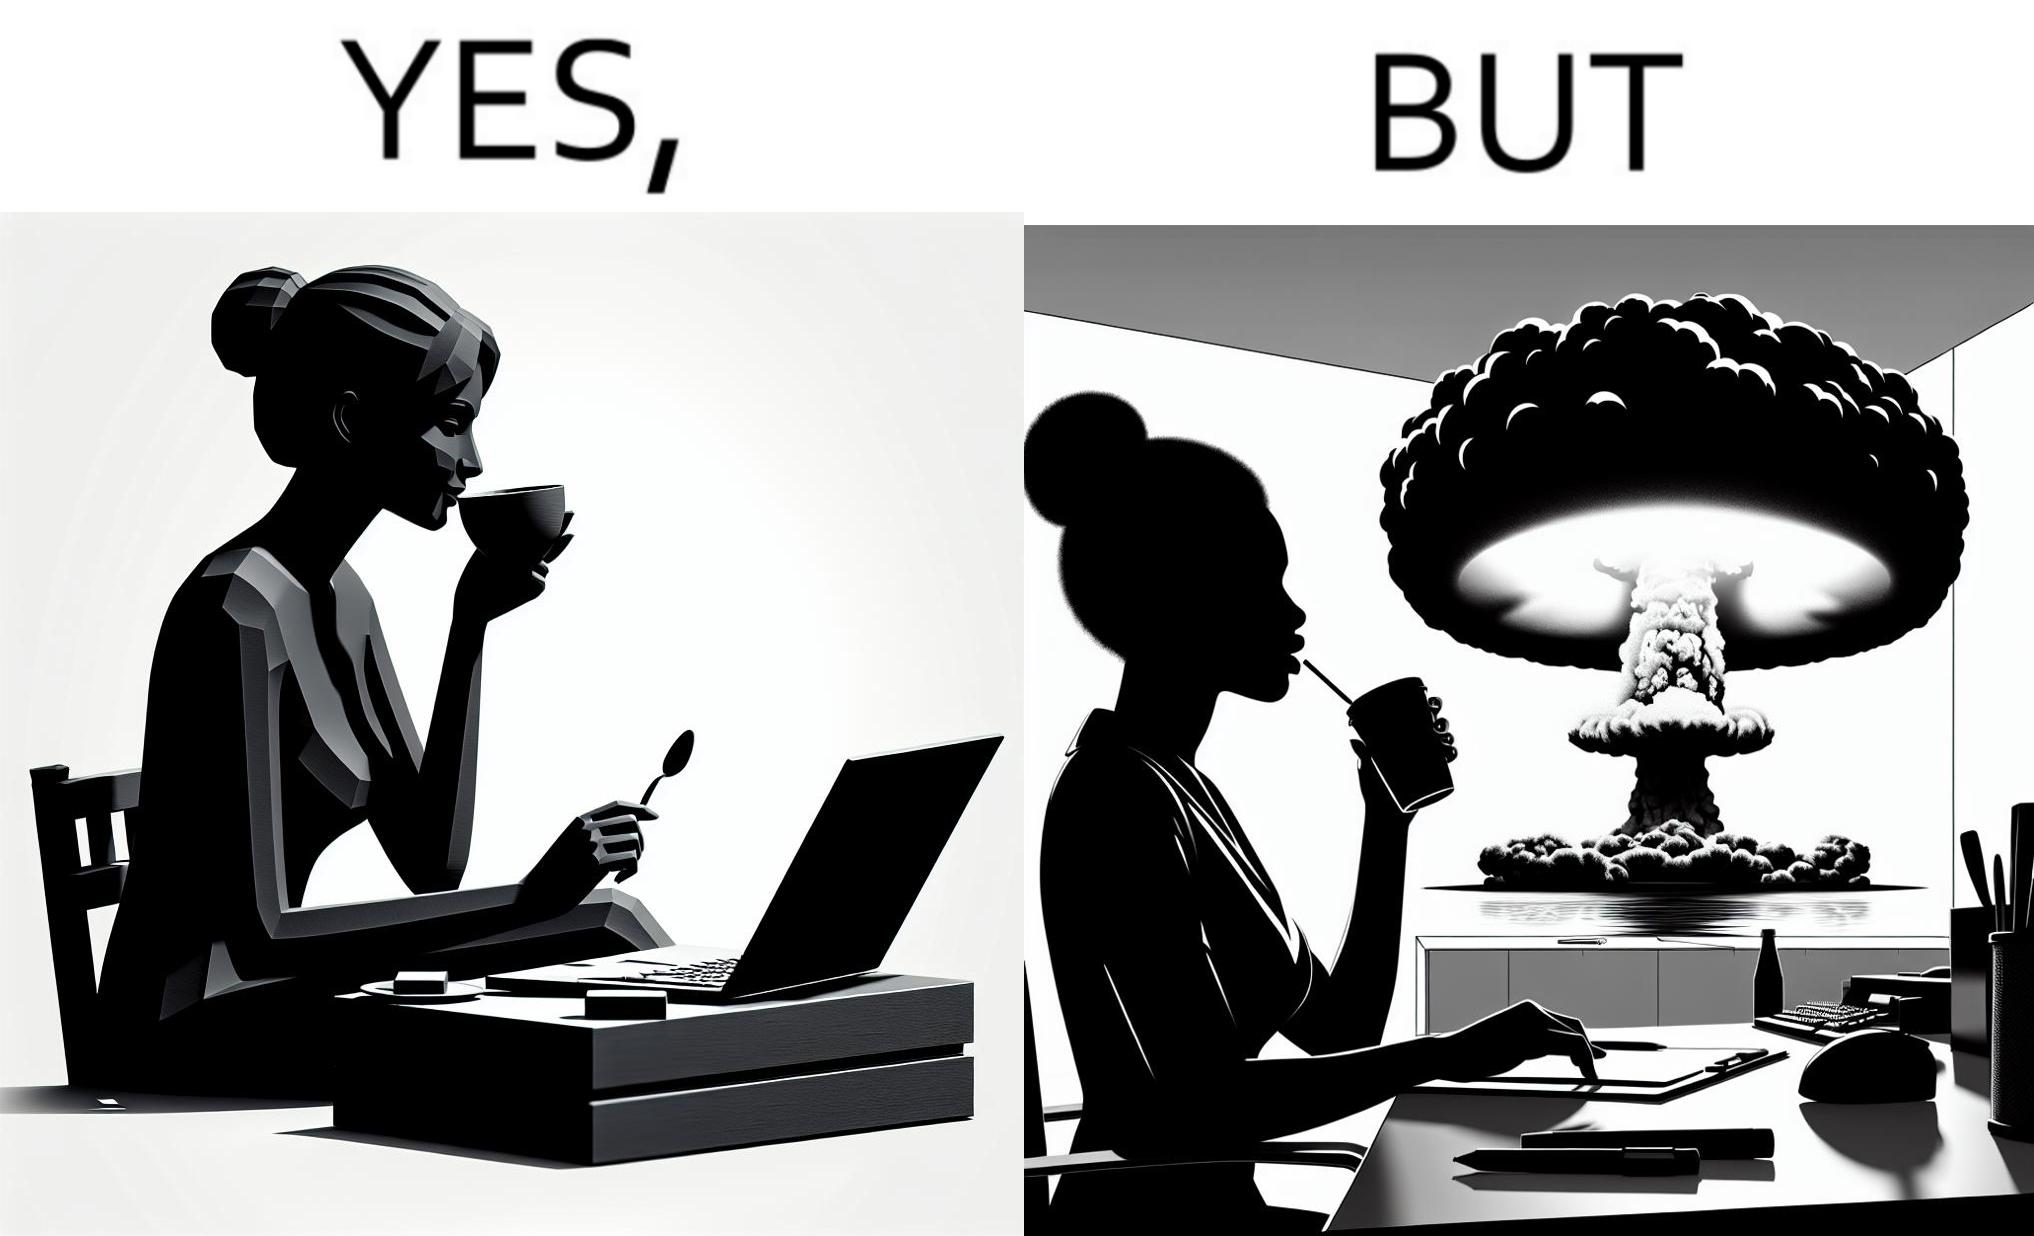Describe what you see in the left and right parts of this image. In the left part of the image: A woman sipping from a cup in a cafe with her laptop In the right part of the image: A woman sipping from a cup while looking at a nuclear blast from her desk 